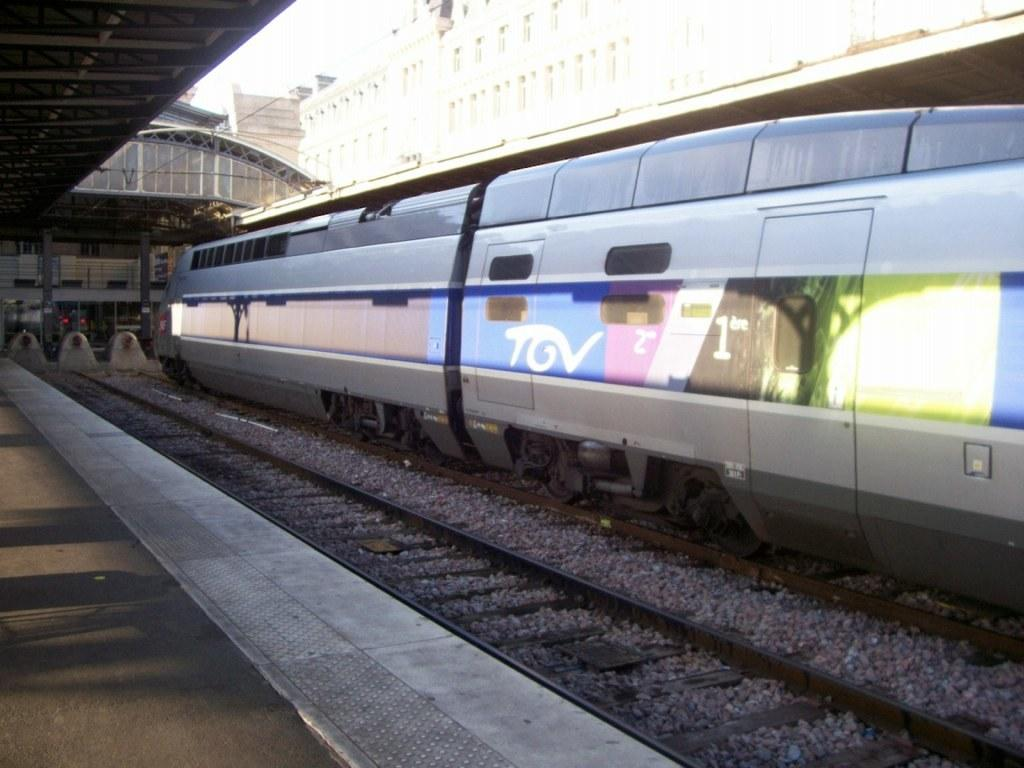<image>
Relay a brief, clear account of the picture shown. A train has the letters TGV on one side. 